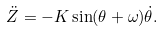<formula> <loc_0><loc_0><loc_500><loc_500>\ddot { Z } = - K \sin ( \theta + \omega ) \dot { \theta } .</formula> 